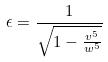Convert formula to latex. <formula><loc_0><loc_0><loc_500><loc_500>\epsilon = \frac { 1 } { \sqrt { 1 - \frac { v ^ { 5 } } { w ^ { 5 } } } }</formula> 